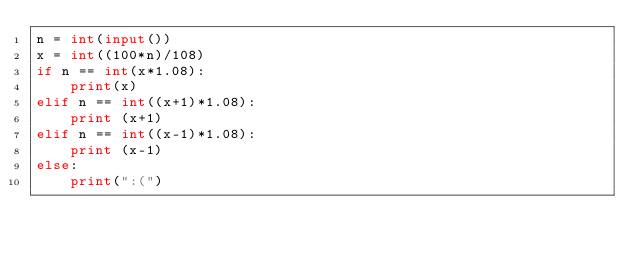<code> <loc_0><loc_0><loc_500><loc_500><_Python_>n = int(input())
x = int((100*n)/108)
if n == int(x*1.08):
    print(x)
elif n == int((x+1)*1.08):
    print (x+1)
elif n == int((x-1)*1.08):
    print (x-1)
else:
    print(":(")</code> 